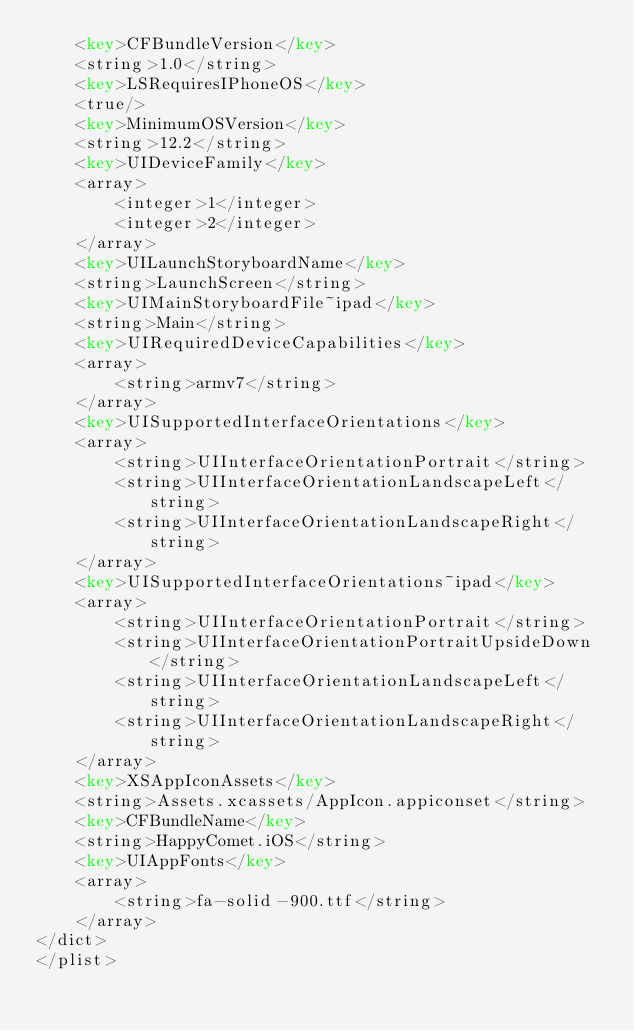<code> <loc_0><loc_0><loc_500><loc_500><_XML_>	<key>CFBundleVersion</key>
	<string>1.0</string>
	<key>LSRequiresIPhoneOS</key>
	<true/>
	<key>MinimumOSVersion</key>
	<string>12.2</string>
	<key>UIDeviceFamily</key>
	<array>
		<integer>1</integer>
		<integer>2</integer>
	</array>
	<key>UILaunchStoryboardName</key>
	<string>LaunchScreen</string>
	<key>UIMainStoryboardFile~ipad</key>
	<string>Main</string>
	<key>UIRequiredDeviceCapabilities</key>
	<array>
		<string>armv7</string>
	</array>
	<key>UISupportedInterfaceOrientations</key>
	<array>
		<string>UIInterfaceOrientationPortrait</string>
		<string>UIInterfaceOrientationLandscapeLeft</string>
		<string>UIInterfaceOrientationLandscapeRight</string>
	</array>
	<key>UISupportedInterfaceOrientations~ipad</key>
	<array>
		<string>UIInterfaceOrientationPortrait</string>
		<string>UIInterfaceOrientationPortraitUpsideDown</string>
		<string>UIInterfaceOrientationLandscapeLeft</string>
		<string>UIInterfaceOrientationLandscapeRight</string>
	</array>
	<key>XSAppIconAssets</key>
	<string>Assets.xcassets/AppIcon.appiconset</string>
	<key>CFBundleName</key>
	<string>HappyComet.iOS</string>
	<key>UIAppFonts</key>
	<array>
		<string>fa-solid-900.ttf</string>
	</array>
</dict>
</plist>
</code> 